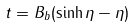Convert formula to latex. <formula><loc_0><loc_0><loc_500><loc_500>t = B _ { b } ( \sinh \eta - \eta )</formula> 